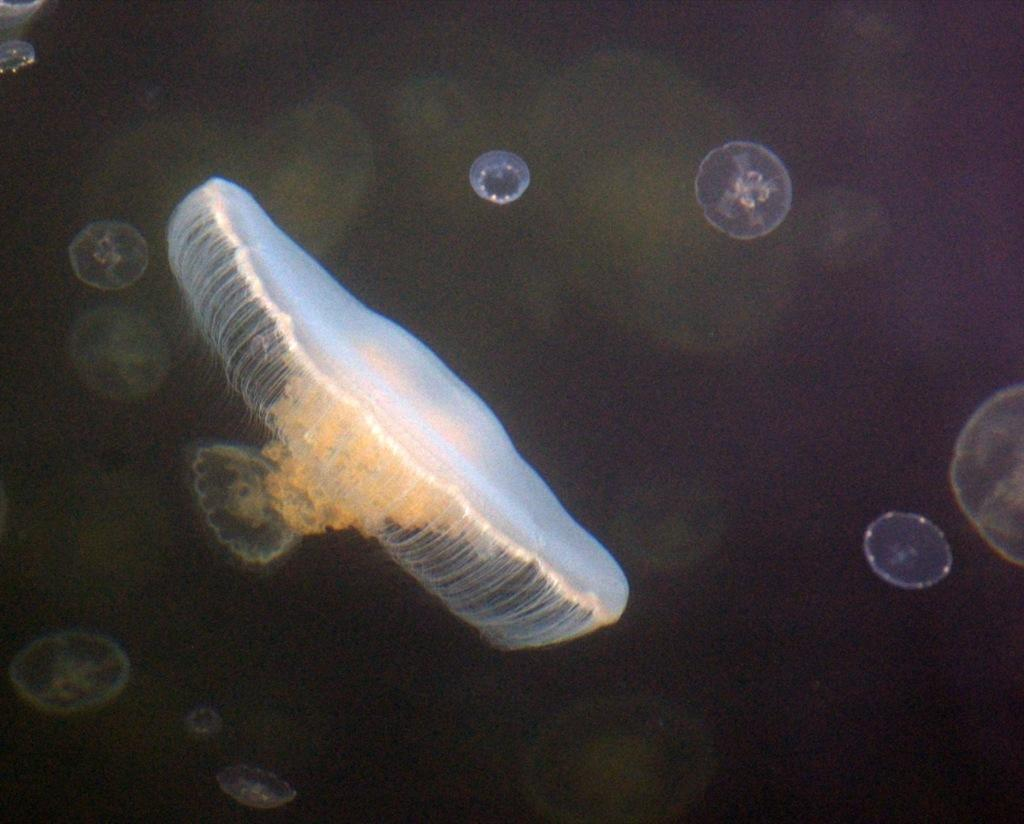What type of animals are in the water in the image? There are jellyfish in the water in the image. What can be seen in the background of the image? The background of the image is dark in color. How does the jellyfish express anger towards its partner in the image? There is no indication of anger or a partner in the image, as it features jellyfish in the water with a dark background. 